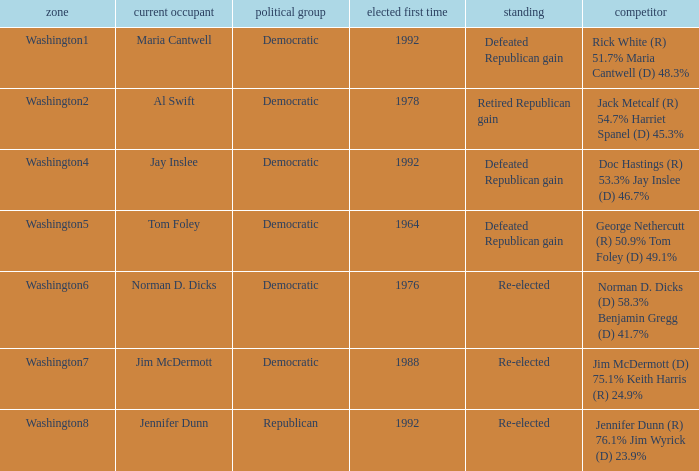What was the result of the election of doc hastings (r) 53.3% jay inslee (d) 46.7% Defeated Republican gain. 